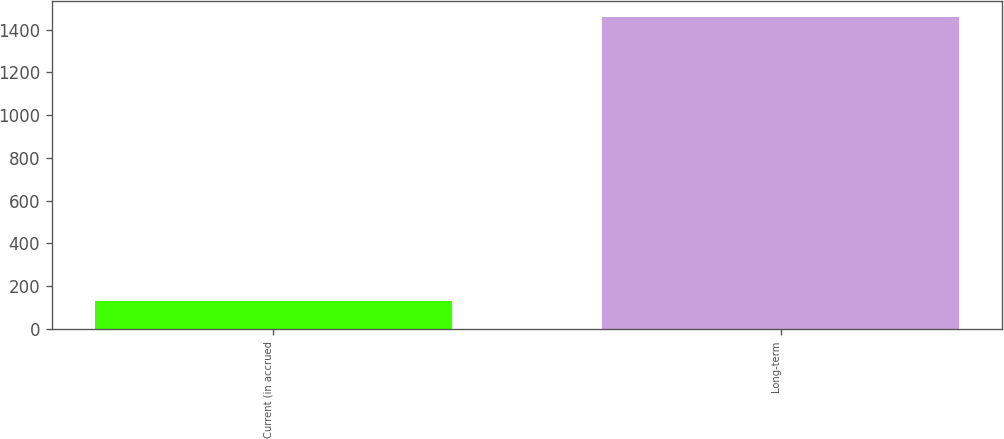<chart> <loc_0><loc_0><loc_500><loc_500><bar_chart><fcel>Current (in accrued<fcel>Long-term<nl><fcel>132<fcel>1459<nl></chart> 